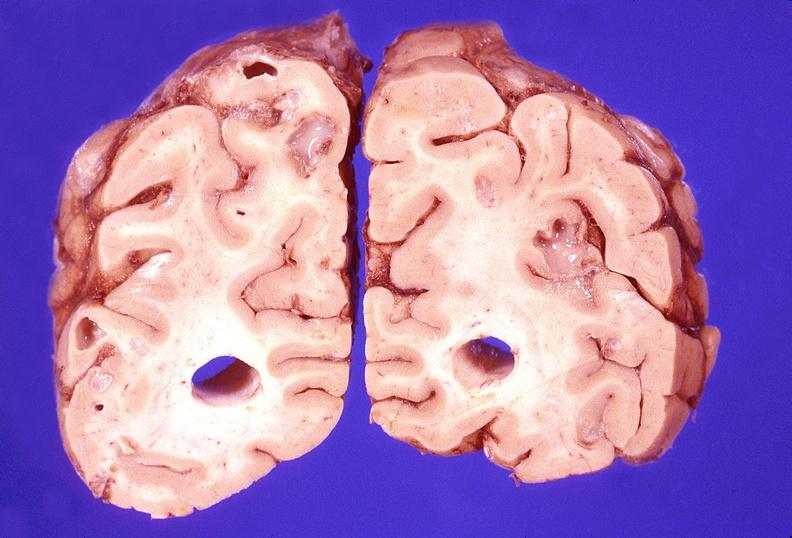what is present?
Answer the question using a single word or phrase. Nervous 